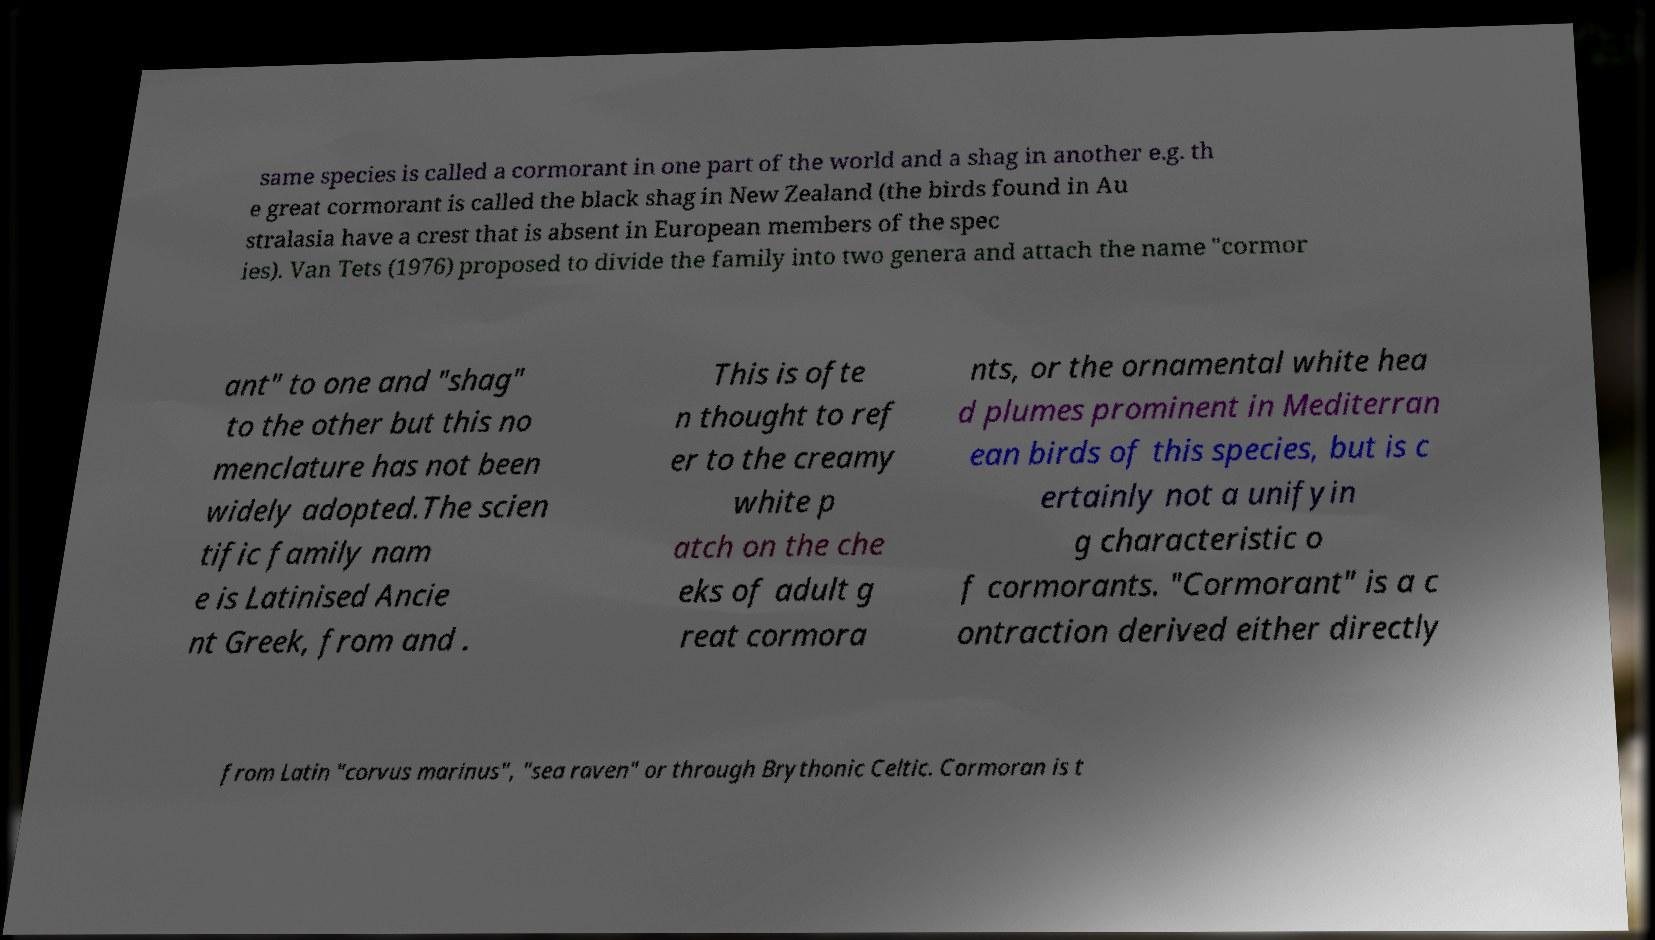There's text embedded in this image that I need extracted. Can you transcribe it verbatim? same species is called a cormorant in one part of the world and a shag in another e.g. th e great cormorant is called the black shag in New Zealand (the birds found in Au stralasia have a crest that is absent in European members of the spec ies). Van Tets (1976) proposed to divide the family into two genera and attach the name "cormor ant" to one and "shag" to the other but this no menclature has not been widely adopted.The scien tific family nam e is Latinised Ancie nt Greek, from and . This is ofte n thought to ref er to the creamy white p atch on the che eks of adult g reat cormora nts, or the ornamental white hea d plumes prominent in Mediterran ean birds of this species, but is c ertainly not a unifyin g characteristic o f cormorants. "Cormorant" is a c ontraction derived either directly from Latin "corvus marinus", "sea raven" or through Brythonic Celtic. Cormoran is t 